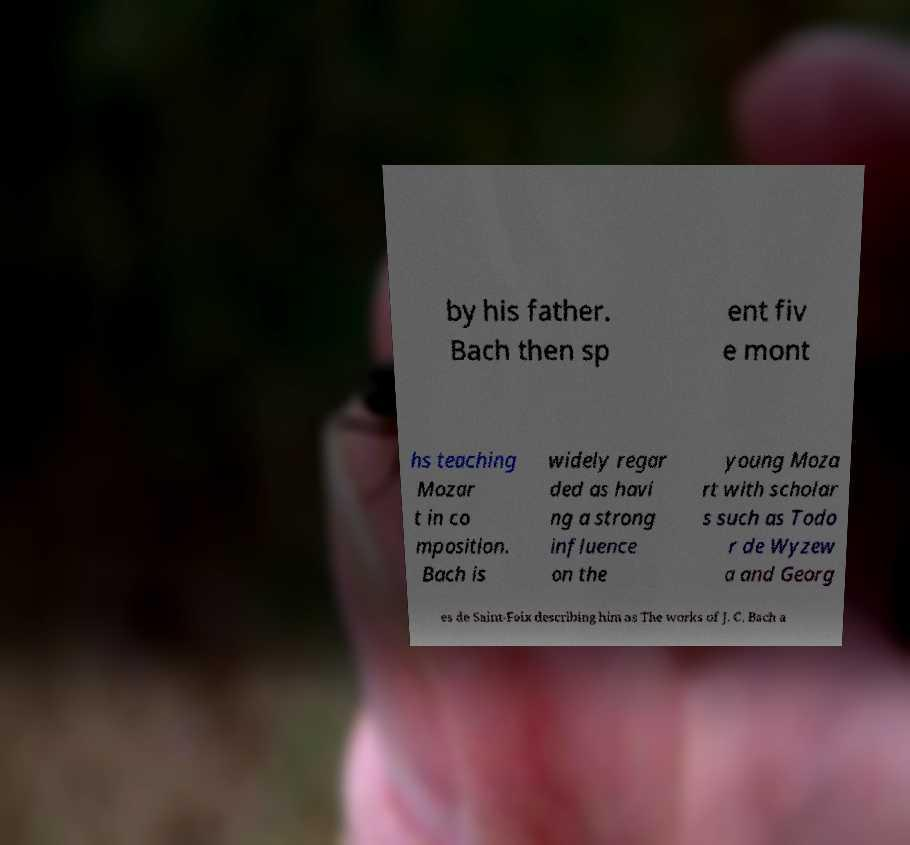Please identify and transcribe the text found in this image. by his father. Bach then sp ent fiv e mont hs teaching Mozar t in co mposition. Bach is widely regar ded as havi ng a strong influence on the young Moza rt with scholar s such as Todo r de Wyzew a and Georg es de Saint-Foix describing him as The works of J. C. Bach a 